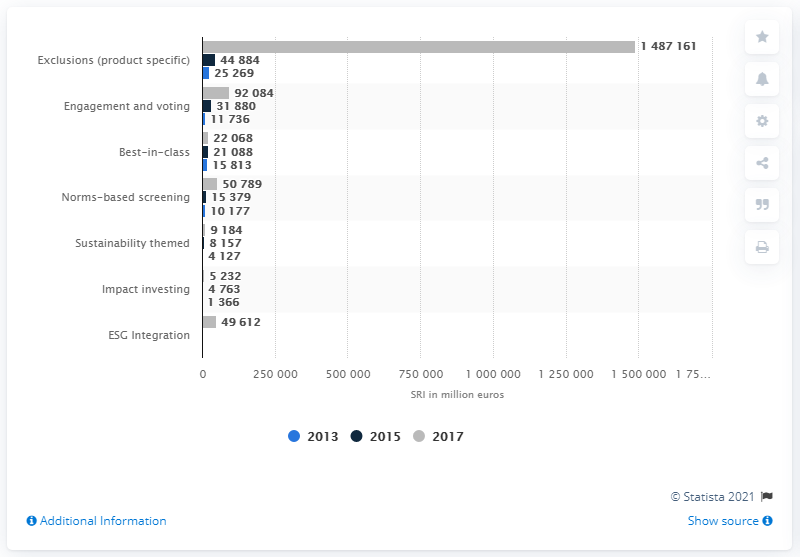Indicate a few pertinent items in this graphic. The amount of exclusions through the "exclusions strategy" in Germany in 2017 was approximately 148,716,100. The exclusions strategy was the dominant responsible investment strategy in Germany in the year 2013. 